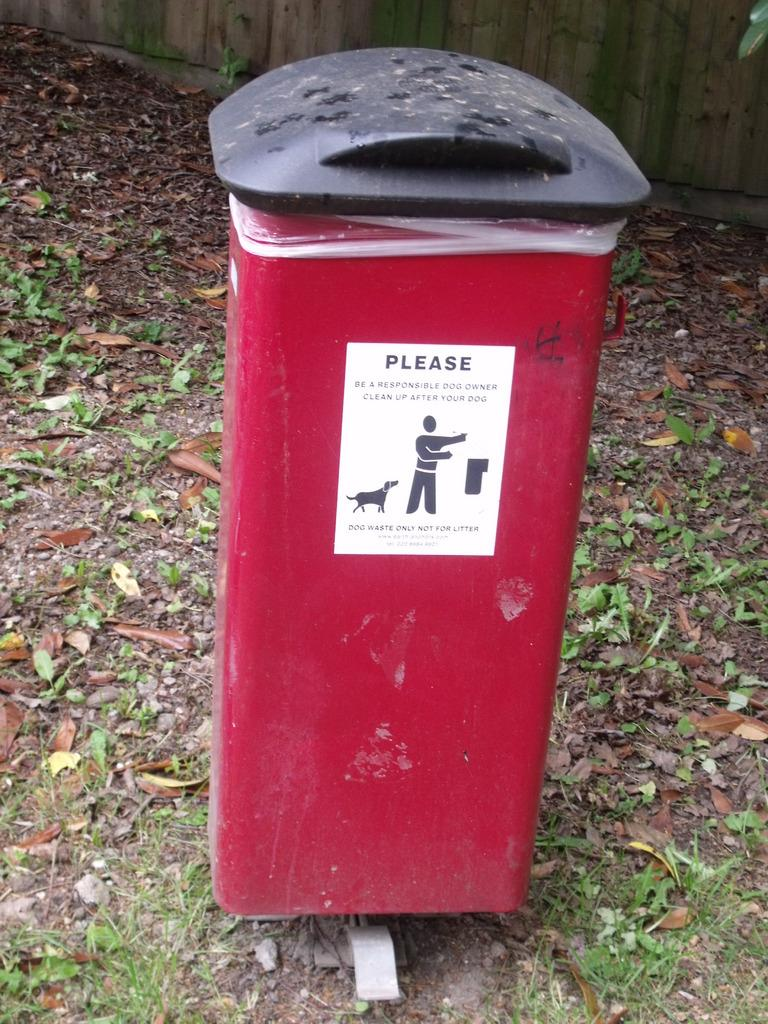<image>
Summarize the visual content of the image. A red waste container is provided to clean up after your dog. 